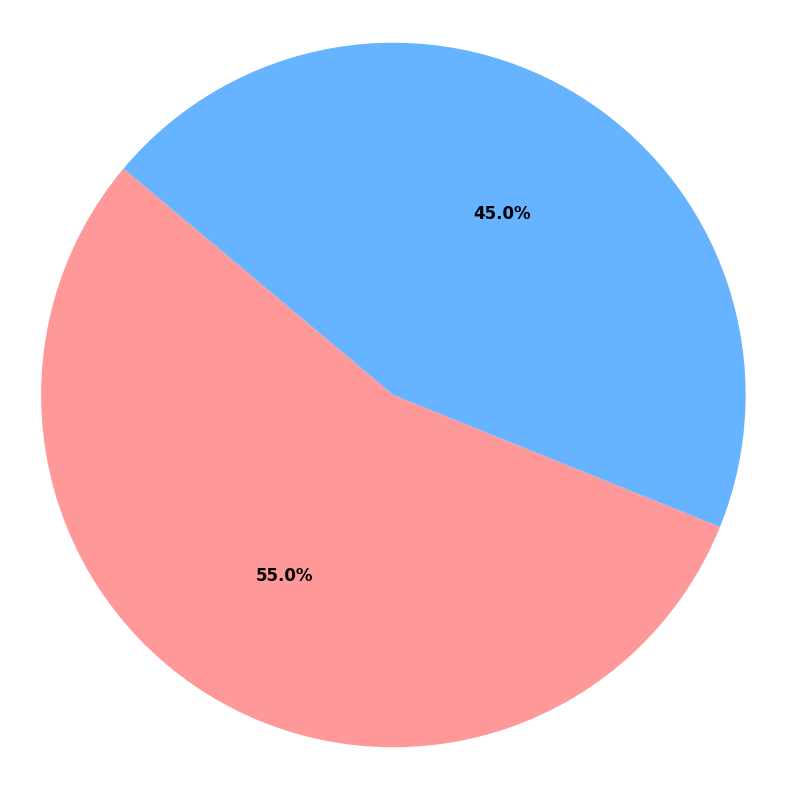What percentage of sales are online? The pie chart shows a section labeled 'Online Sales' with the percentage indicated on the slice. This percentage is the proportion of online sales out of the total sales.
Answer: 55% What is the difference in percentage between online and in-store sales? The pie chart shows the percentage of online sales as 55% and in-store sales as 45%. To find the difference, subtract the smaller percentage from the larger one: 55% - 45% = 10%.
Answer: 10% Are online sales greater than in-store sales? By observing the pie chart, the online sales section is larger than the in-store sales section, with percentages labeled as 55% for online and 45% for in-store.
Answer: Yes Which sales channel has a higher share, online or in-store? The pie chart displays two sections with percentages. The 'Online Sales' section is larger, indicating a higher share. It is explicitly labeled as 55%, compared to 45% for 'In-Store Sales.'
Answer: Online Combined, what percentage of sales comes from online and in-store channels? The pie chart represents the entirety of the sales, which means that the sum of 'Online Sales' and 'In-Store Sales' sections must be the total sales. Adding 55% (online) and 45% (in-store) gives 100%.
Answer: 100% If we wanted to raise in-store sales to be equal to online sales, by what percentage would in-store sales need to increase? Currently, in-store sales are at 45%, and online sales are at 55%. To make them equal, both should be at 50%. In-store sales need to increase from 45% to 50%, which is a 5% increase.
Answer: 5% What color represents online sales in the pie chart? The pie chart uses different colors for each section. Online sales are represented by a reddish color.
Answer: Red How do the font sizes of labels and percentage values compare in the pie chart? The pie chart style settings specify larger font sizes for the labels ('Online Sales' and 'In-Store Sales') and slightly smaller sizes for the percentage values.
Answer: Labels are larger Is the percentage of in-store sales less than 50%? According to the pie chart, the percentage for in-store sales is shown as 45%, which is less than 50%.
Answer: Yes 